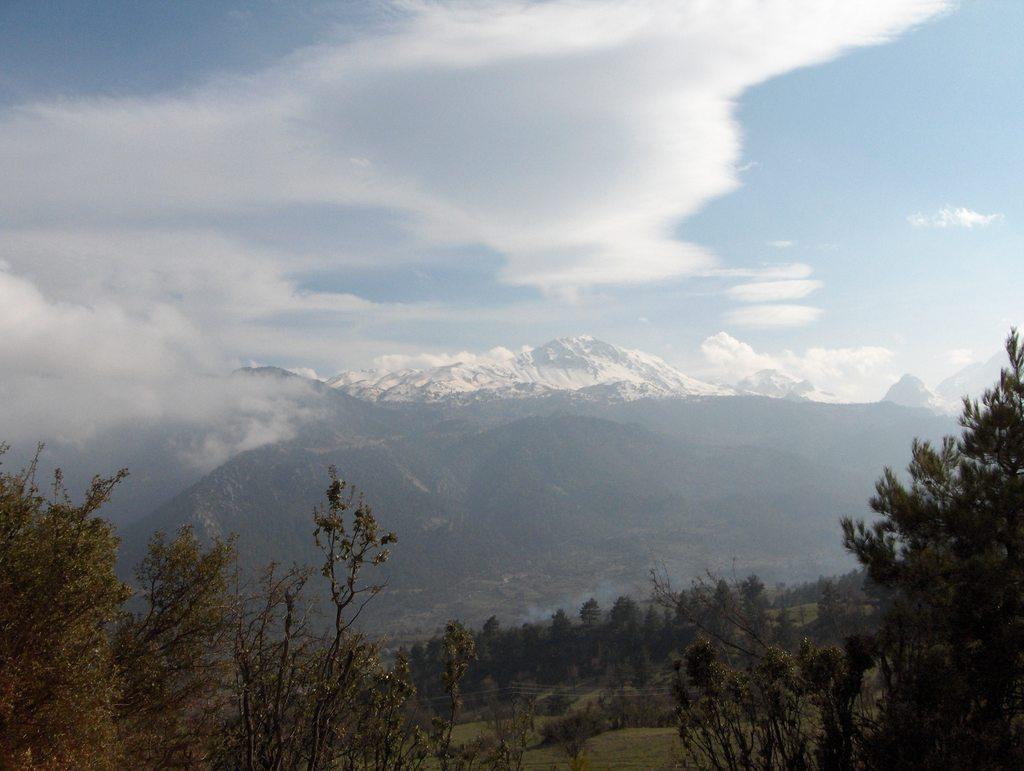Describe this image in one or two sentences. In the center of the image there are trees,mountains. In the background of the image there are snow mountains,sky,clouds. 